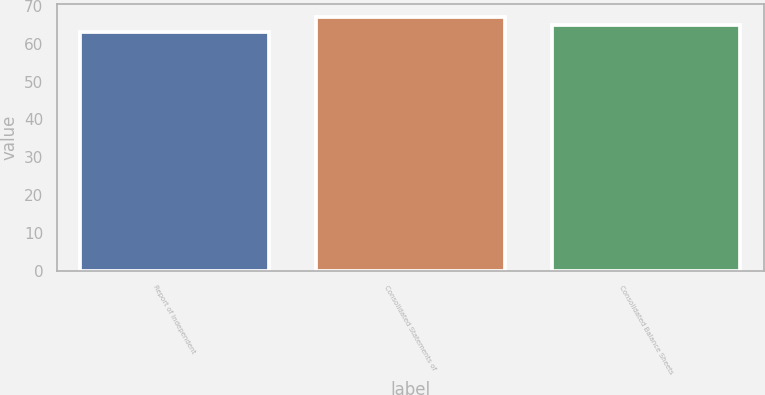Convert chart to OTSL. <chart><loc_0><loc_0><loc_500><loc_500><bar_chart><fcel>Report of Independent<fcel>Consolidated Statements of<fcel>Consolidated Balance Sheets<nl><fcel>63<fcel>67<fcel>65<nl></chart> 